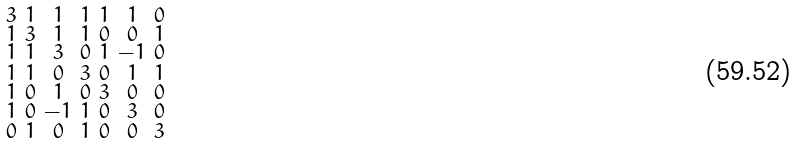<formula> <loc_0><loc_0><loc_500><loc_500>\begin{smallmatrix} 3 & 1 & 1 & 1 & 1 & 1 & 0 \\ 1 & 3 & 1 & 1 & 0 & 0 & 1 \\ 1 & 1 & 3 & 0 & 1 & - 1 & 0 \\ 1 & 1 & 0 & 3 & 0 & 1 & 1 \\ 1 & 0 & 1 & 0 & 3 & 0 & 0 \\ 1 & 0 & - 1 & 1 & 0 & 3 & 0 \\ 0 & 1 & 0 & 1 & 0 & 0 & 3 \end{smallmatrix}</formula> 